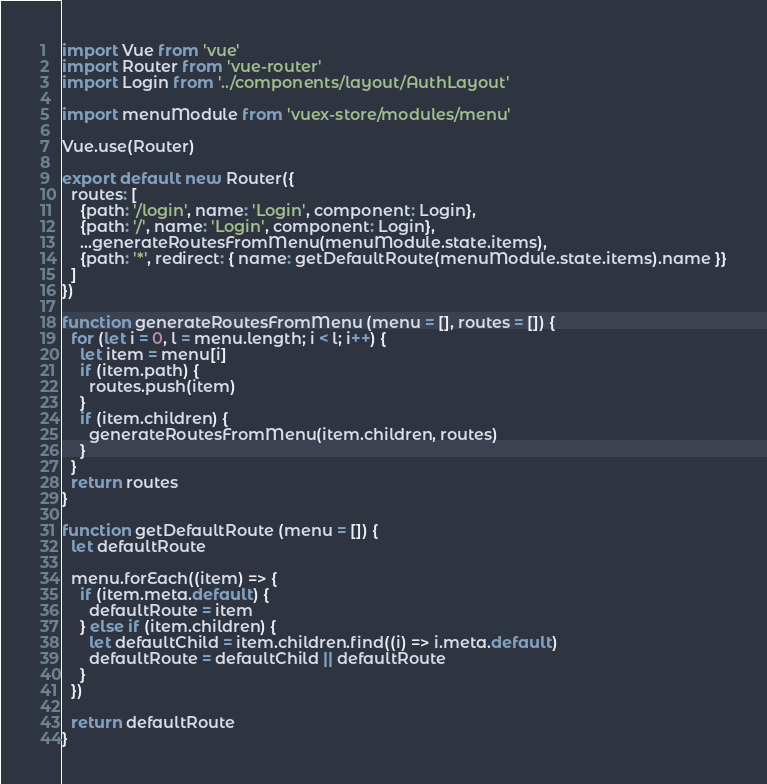<code> <loc_0><loc_0><loc_500><loc_500><_JavaScript_>import Vue from 'vue'
import Router from 'vue-router'
import Login from '../components/layout/AuthLayout'

import menuModule from 'vuex-store/modules/menu'

Vue.use(Router)

export default new Router({
  routes: [
    {path: '/login', name: 'Login', component: Login},
    {path: '/', name: 'Login', component: Login},
    ...generateRoutesFromMenu(menuModule.state.items),
    {path: '*', redirect: { name: getDefaultRoute(menuModule.state.items).name }}
  ]
})

function generateRoutesFromMenu (menu = [], routes = []) {
  for (let i = 0, l = menu.length; i < l; i++) {
    let item = menu[i]
    if (item.path) {
      routes.push(item)
    }
    if (item.children) {
      generateRoutesFromMenu(item.children, routes)
    }
  }
  return routes
}

function getDefaultRoute (menu = []) {
  let defaultRoute

  menu.forEach((item) => {
    if (item.meta.default) {
      defaultRoute = item
    } else if (item.children) {
      let defaultChild = item.children.find((i) => i.meta.default)
      defaultRoute = defaultChild || defaultRoute
    }
  })

  return defaultRoute
}
</code> 